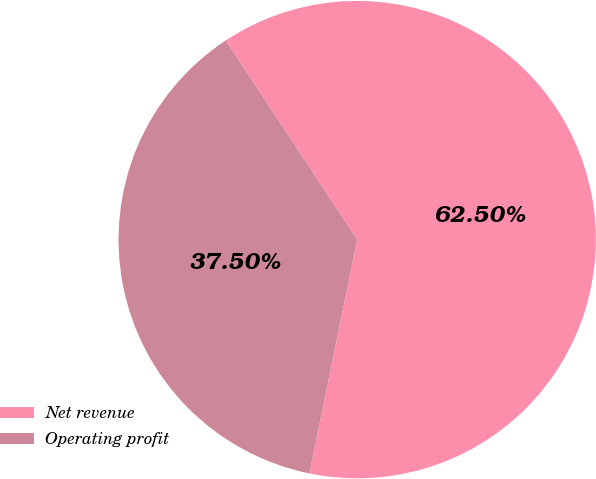Convert chart. <chart><loc_0><loc_0><loc_500><loc_500><pie_chart><fcel>Net revenue<fcel>Operating profit<nl><fcel>62.5%<fcel>37.5%<nl></chart> 